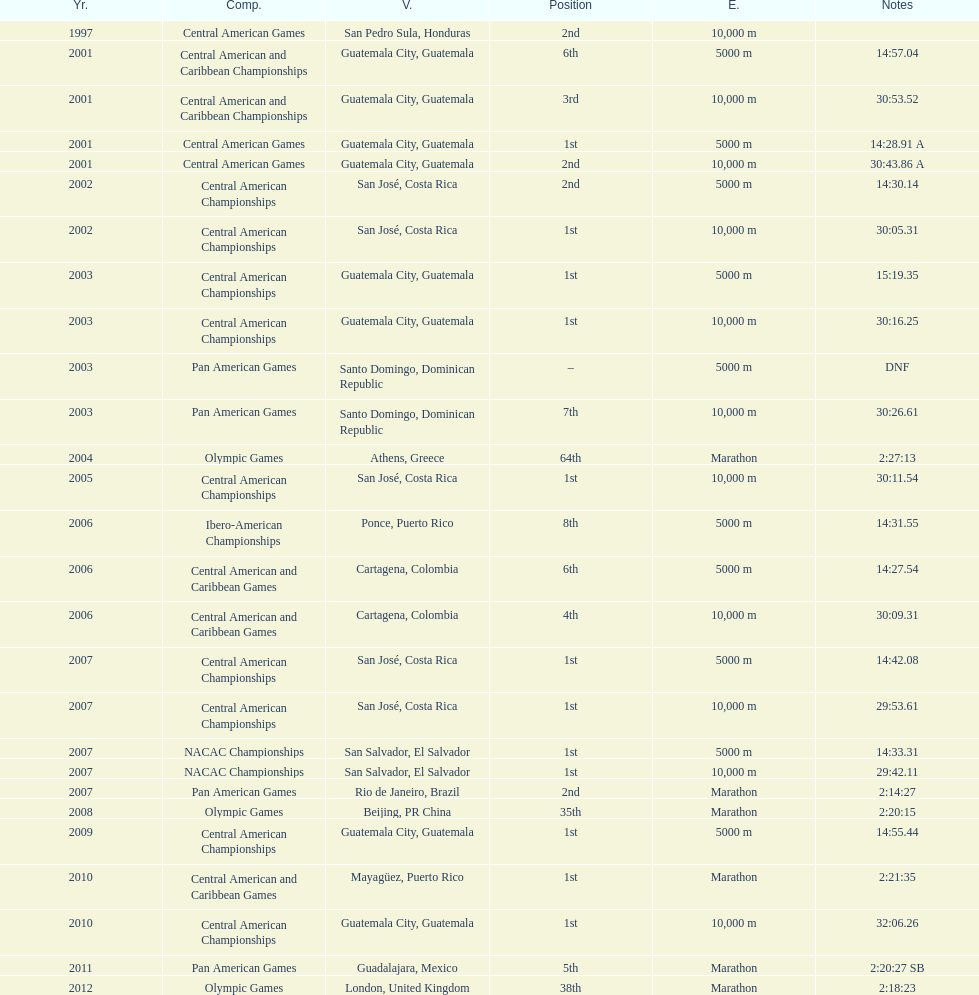How many times has the position of 1st been achieved? 12. 